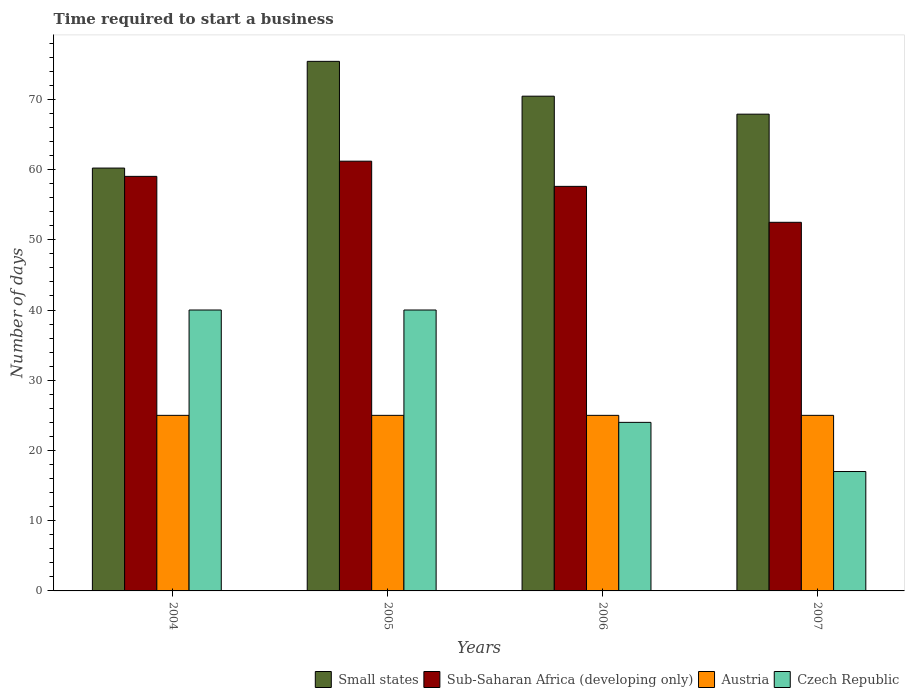How many different coloured bars are there?
Keep it short and to the point. 4. Are the number of bars on each tick of the X-axis equal?
Offer a terse response. Yes. In how many cases, is the number of bars for a given year not equal to the number of legend labels?
Your answer should be very brief. 0. What is the number of days required to start a business in Sub-Saharan Africa (developing only) in 2005?
Provide a succinct answer. 61.19. Across all years, what is the maximum number of days required to start a business in Austria?
Keep it short and to the point. 25. In which year was the number of days required to start a business in Small states maximum?
Your answer should be very brief. 2005. What is the total number of days required to start a business in Czech Republic in the graph?
Make the answer very short. 121. What is the difference between the number of days required to start a business in Small states in 2005 and that in 2006?
Provide a succinct answer. 4.96. What is the difference between the number of days required to start a business in Sub-Saharan Africa (developing only) in 2005 and the number of days required to start a business in Austria in 2004?
Provide a short and direct response. 36.19. What is the average number of days required to start a business in Small states per year?
Keep it short and to the point. 68.49. What is the ratio of the number of days required to start a business in Small states in 2006 to that in 2007?
Your answer should be compact. 1.04. What is the difference between the highest and the second highest number of days required to start a business in Austria?
Give a very brief answer. 0. What is the difference between the highest and the lowest number of days required to start a business in Sub-Saharan Africa (developing only)?
Offer a terse response. 8.7. Is it the case that in every year, the sum of the number of days required to start a business in Czech Republic and number of days required to start a business in Small states is greater than the sum of number of days required to start a business in Austria and number of days required to start a business in Sub-Saharan Africa (developing only)?
Provide a succinct answer. Yes. What does the 4th bar from the left in 2004 represents?
Give a very brief answer. Czech Republic. What does the 4th bar from the right in 2004 represents?
Keep it short and to the point. Small states. Is it the case that in every year, the sum of the number of days required to start a business in Sub-Saharan Africa (developing only) and number of days required to start a business in Czech Republic is greater than the number of days required to start a business in Small states?
Provide a short and direct response. Yes. Are all the bars in the graph horizontal?
Your answer should be compact. No. What is the difference between two consecutive major ticks on the Y-axis?
Provide a succinct answer. 10. Are the values on the major ticks of Y-axis written in scientific E-notation?
Make the answer very short. No. Where does the legend appear in the graph?
Give a very brief answer. Bottom right. How many legend labels are there?
Your answer should be very brief. 4. How are the legend labels stacked?
Your response must be concise. Horizontal. What is the title of the graph?
Offer a terse response. Time required to start a business. What is the label or title of the Y-axis?
Offer a very short reply. Number of days. What is the Number of days of Small states in 2004?
Ensure brevity in your answer.  60.21. What is the Number of days in Sub-Saharan Africa (developing only) in 2004?
Give a very brief answer. 59.03. What is the Number of days in Austria in 2004?
Give a very brief answer. 25. What is the Number of days in Small states in 2005?
Offer a terse response. 75.41. What is the Number of days of Sub-Saharan Africa (developing only) in 2005?
Offer a very short reply. 61.19. What is the Number of days in Czech Republic in 2005?
Your answer should be very brief. 40. What is the Number of days of Small states in 2006?
Ensure brevity in your answer.  70.45. What is the Number of days of Sub-Saharan Africa (developing only) in 2006?
Provide a succinct answer. 57.6. What is the Number of days in Austria in 2006?
Provide a short and direct response. 25. What is the Number of days in Czech Republic in 2006?
Your answer should be compact. 24. What is the Number of days of Small states in 2007?
Ensure brevity in your answer.  67.88. What is the Number of days of Sub-Saharan Africa (developing only) in 2007?
Your answer should be compact. 52.49. What is the Number of days in Czech Republic in 2007?
Offer a terse response. 17. Across all years, what is the maximum Number of days in Small states?
Your answer should be very brief. 75.41. Across all years, what is the maximum Number of days of Sub-Saharan Africa (developing only)?
Your answer should be very brief. 61.19. Across all years, what is the maximum Number of days in Austria?
Provide a short and direct response. 25. Across all years, what is the minimum Number of days of Small states?
Ensure brevity in your answer.  60.21. Across all years, what is the minimum Number of days in Sub-Saharan Africa (developing only)?
Make the answer very short. 52.49. Across all years, what is the minimum Number of days in Austria?
Your response must be concise. 25. What is the total Number of days of Small states in the graph?
Your response must be concise. 273.95. What is the total Number of days of Sub-Saharan Africa (developing only) in the graph?
Your response must be concise. 230.31. What is the total Number of days in Austria in the graph?
Offer a very short reply. 100. What is the total Number of days in Czech Republic in the graph?
Your response must be concise. 121. What is the difference between the Number of days of Small states in 2004 and that in 2005?
Offer a very short reply. -15.19. What is the difference between the Number of days in Sub-Saharan Africa (developing only) in 2004 and that in 2005?
Your answer should be compact. -2.16. What is the difference between the Number of days in Austria in 2004 and that in 2005?
Offer a very short reply. 0. What is the difference between the Number of days of Czech Republic in 2004 and that in 2005?
Your response must be concise. 0. What is the difference between the Number of days of Small states in 2004 and that in 2006?
Offer a terse response. -10.24. What is the difference between the Number of days of Sub-Saharan Africa (developing only) in 2004 and that in 2006?
Give a very brief answer. 1.42. What is the difference between the Number of days of Small states in 2004 and that in 2007?
Keep it short and to the point. -7.67. What is the difference between the Number of days of Sub-Saharan Africa (developing only) in 2004 and that in 2007?
Ensure brevity in your answer.  6.54. What is the difference between the Number of days of Austria in 2004 and that in 2007?
Your answer should be compact. 0. What is the difference between the Number of days of Small states in 2005 and that in 2006?
Your answer should be very brief. 4.96. What is the difference between the Number of days in Sub-Saharan Africa (developing only) in 2005 and that in 2006?
Keep it short and to the point. 3.59. What is the difference between the Number of days of Austria in 2005 and that in 2006?
Give a very brief answer. 0. What is the difference between the Number of days in Small states in 2005 and that in 2007?
Provide a succinct answer. 7.52. What is the difference between the Number of days of Sub-Saharan Africa (developing only) in 2005 and that in 2007?
Your answer should be compact. 8.7. What is the difference between the Number of days in Small states in 2006 and that in 2007?
Offer a terse response. 2.56. What is the difference between the Number of days in Sub-Saharan Africa (developing only) in 2006 and that in 2007?
Provide a short and direct response. 5.12. What is the difference between the Number of days of Austria in 2006 and that in 2007?
Ensure brevity in your answer.  0. What is the difference between the Number of days of Czech Republic in 2006 and that in 2007?
Keep it short and to the point. 7. What is the difference between the Number of days of Small states in 2004 and the Number of days of Sub-Saharan Africa (developing only) in 2005?
Keep it short and to the point. -0.98. What is the difference between the Number of days in Small states in 2004 and the Number of days in Austria in 2005?
Your answer should be very brief. 35.21. What is the difference between the Number of days of Small states in 2004 and the Number of days of Czech Republic in 2005?
Your answer should be compact. 20.21. What is the difference between the Number of days of Sub-Saharan Africa (developing only) in 2004 and the Number of days of Austria in 2005?
Your answer should be very brief. 34.03. What is the difference between the Number of days of Sub-Saharan Africa (developing only) in 2004 and the Number of days of Czech Republic in 2005?
Your response must be concise. 19.03. What is the difference between the Number of days in Small states in 2004 and the Number of days in Sub-Saharan Africa (developing only) in 2006?
Your response must be concise. 2.61. What is the difference between the Number of days in Small states in 2004 and the Number of days in Austria in 2006?
Make the answer very short. 35.21. What is the difference between the Number of days in Small states in 2004 and the Number of days in Czech Republic in 2006?
Make the answer very short. 36.21. What is the difference between the Number of days in Sub-Saharan Africa (developing only) in 2004 and the Number of days in Austria in 2006?
Keep it short and to the point. 34.03. What is the difference between the Number of days of Sub-Saharan Africa (developing only) in 2004 and the Number of days of Czech Republic in 2006?
Your response must be concise. 35.03. What is the difference between the Number of days in Small states in 2004 and the Number of days in Sub-Saharan Africa (developing only) in 2007?
Provide a short and direct response. 7.72. What is the difference between the Number of days of Small states in 2004 and the Number of days of Austria in 2007?
Offer a terse response. 35.21. What is the difference between the Number of days of Small states in 2004 and the Number of days of Czech Republic in 2007?
Your answer should be very brief. 43.21. What is the difference between the Number of days in Sub-Saharan Africa (developing only) in 2004 and the Number of days in Austria in 2007?
Provide a succinct answer. 34.03. What is the difference between the Number of days of Sub-Saharan Africa (developing only) in 2004 and the Number of days of Czech Republic in 2007?
Provide a short and direct response. 42.03. What is the difference between the Number of days of Small states in 2005 and the Number of days of Sub-Saharan Africa (developing only) in 2006?
Give a very brief answer. 17.8. What is the difference between the Number of days in Small states in 2005 and the Number of days in Austria in 2006?
Your answer should be compact. 50.41. What is the difference between the Number of days of Small states in 2005 and the Number of days of Czech Republic in 2006?
Make the answer very short. 51.41. What is the difference between the Number of days in Sub-Saharan Africa (developing only) in 2005 and the Number of days in Austria in 2006?
Your answer should be compact. 36.19. What is the difference between the Number of days in Sub-Saharan Africa (developing only) in 2005 and the Number of days in Czech Republic in 2006?
Provide a succinct answer. 37.19. What is the difference between the Number of days in Austria in 2005 and the Number of days in Czech Republic in 2006?
Your response must be concise. 1. What is the difference between the Number of days in Small states in 2005 and the Number of days in Sub-Saharan Africa (developing only) in 2007?
Ensure brevity in your answer.  22.92. What is the difference between the Number of days of Small states in 2005 and the Number of days of Austria in 2007?
Your answer should be very brief. 50.41. What is the difference between the Number of days of Small states in 2005 and the Number of days of Czech Republic in 2007?
Your answer should be compact. 58.41. What is the difference between the Number of days of Sub-Saharan Africa (developing only) in 2005 and the Number of days of Austria in 2007?
Offer a terse response. 36.19. What is the difference between the Number of days of Sub-Saharan Africa (developing only) in 2005 and the Number of days of Czech Republic in 2007?
Your answer should be very brief. 44.19. What is the difference between the Number of days in Small states in 2006 and the Number of days in Sub-Saharan Africa (developing only) in 2007?
Your answer should be compact. 17.96. What is the difference between the Number of days in Small states in 2006 and the Number of days in Austria in 2007?
Ensure brevity in your answer.  45.45. What is the difference between the Number of days in Small states in 2006 and the Number of days in Czech Republic in 2007?
Offer a very short reply. 53.45. What is the difference between the Number of days in Sub-Saharan Africa (developing only) in 2006 and the Number of days in Austria in 2007?
Offer a terse response. 32.6. What is the difference between the Number of days in Sub-Saharan Africa (developing only) in 2006 and the Number of days in Czech Republic in 2007?
Keep it short and to the point. 40.6. What is the average Number of days in Small states per year?
Offer a terse response. 68.49. What is the average Number of days of Sub-Saharan Africa (developing only) per year?
Make the answer very short. 57.58. What is the average Number of days in Austria per year?
Provide a succinct answer. 25. What is the average Number of days in Czech Republic per year?
Your answer should be very brief. 30.25. In the year 2004, what is the difference between the Number of days in Small states and Number of days in Sub-Saharan Africa (developing only)?
Give a very brief answer. 1.18. In the year 2004, what is the difference between the Number of days in Small states and Number of days in Austria?
Offer a terse response. 35.21. In the year 2004, what is the difference between the Number of days in Small states and Number of days in Czech Republic?
Offer a terse response. 20.21. In the year 2004, what is the difference between the Number of days of Sub-Saharan Africa (developing only) and Number of days of Austria?
Your response must be concise. 34.03. In the year 2004, what is the difference between the Number of days in Sub-Saharan Africa (developing only) and Number of days in Czech Republic?
Your answer should be very brief. 19.03. In the year 2005, what is the difference between the Number of days in Small states and Number of days in Sub-Saharan Africa (developing only)?
Offer a very short reply. 14.21. In the year 2005, what is the difference between the Number of days in Small states and Number of days in Austria?
Offer a very short reply. 50.41. In the year 2005, what is the difference between the Number of days in Small states and Number of days in Czech Republic?
Make the answer very short. 35.41. In the year 2005, what is the difference between the Number of days of Sub-Saharan Africa (developing only) and Number of days of Austria?
Your answer should be compact. 36.19. In the year 2005, what is the difference between the Number of days in Sub-Saharan Africa (developing only) and Number of days in Czech Republic?
Offer a very short reply. 21.19. In the year 2006, what is the difference between the Number of days of Small states and Number of days of Sub-Saharan Africa (developing only)?
Your answer should be very brief. 12.84. In the year 2006, what is the difference between the Number of days in Small states and Number of days in Austria?
Make the answer very short. 45.45. In the year 2006, what is the difference between the Number of days in Small states and Number of days in Czech Republic?
Make the answer very short. 46.45. In the year 2006, what is the difference between the Number of days of Sub-Saharan Africa (developing only) and Number of days of Austria?
Keep it short and to the point. 32.6. In the year 2006, what is the difference between the Number of days of Sub-Saharan Africa (developing only) and Number of days of Czech Republic?
Offer a terse response. 33.6. In the year 2006, what is the difference between the Number of days of Austria and Number of days of Czech Republic?
Offer a very short reply. 1. In the year 2007, what is the difference between the Number of days in Small states and Number of days in Sub-Saharan Africa (developing only)?
Keep it short and to the point. 15.4. In the year 2007, what is the difference between the Number of days of Small states and Number of days of Austria?
Your response must be concise. 42.88. In the year 2007, what is the difference between the Number of days of Small states and Number of days of Czech Republic?
Your answer should be compact. 50.88. In the year 2007, what is the difference between the Number of days in Sub-Saharan Africa (developing only) and Number of days in Austria?
Your answer should be compact. 27.49. In the year 2007, what is the difference between the Number of days in Sub-Saharan Africa (developing only) and Number of days in Czech Republic?
Make the answer very short. 35.49. In the year 2007, what is the difference between the Number of days of Austria and Number of days of Czech Republic?
Provide a short and direct response. 8. What is the ratio of the Number of days in Small states in 2004 to that in 2005?
Offer a terse response. 0.8. What is the ratio of the Number of days in Sub-Saharan Africa (developing only) in 2004 to that in 2005?
Ensure brevity in your answer.  0.96. What is the ratio of the Number of days of Austria in 2004 to that in 2005?
Provide a succinct answer. 1. What is the ratio of the Number of days in Czech Republic in 2004 to that in 2005?
Provide a short and direct response. 1. What is the ratio of the Number of days of Small states in 2004 to that in 2006?
Offer a terse response. 0.85. What is the ratio of the Number of days in Sub-Saharan Africa (developing only) in 2004 to that in 2006?
Provide a succinct answer. 1.02. What is the ratio of the Number of days of Austria in 2004 to that in 2006?
Provide a succinct answer. 1. What is the ratio of the Number of days in Small states in 2004 to that in 2007?
Your answer should be very brief. 0.89. What is the ratio of the Number of days of Sub-Saharan Africa (developing only) in 2004 to that in 2007?
Your response must be concise. 1.12. What is the ratio of the Number of days of Czech Republic in 2004 to that in 2007?
Your response must be concise. 2.35. What is the ratio of the Number of days of Small states in 2005 to that in 2006?
Your answer should be compact. 1.07. What is the ratio of the Number of days of Sub-Saharan Africa (developing only) in 2005 to that in 2006?
Your answer should be compact. 1.06. What is the ratio of the Number of days in Small states in 2005 to that in 2007?
Offer a very short reply. 1.11. What is the ratio of the Number of days in Sub-Saharan Africa (developing only) in 2005 to that in 2007?
Make the answer very short. 1.17. What is the ratio of the Number of days of Czech Republic in 2005 to that in 2007?
Your answer should be compact. 2.35. What is the ratio of the Number of days in Small states in 2006 to that in 2007?
Your answer should be compact. 1.04. What is the ratio of the Number of days of Sub-Saharan Africa (developing only) in 2006 to that in 2007?
Offer a very short reply. 1.1. What is the ratio of the Number of days in Czech Republic in 2006 to that in 2007?
Give a very brief answer. 1.41. What is the difference between the highest and the second highest Number of days in Small states?
Ensure brevity in your answer.  4.96. What is the difference between the highest and the second highest Number of days of Sub-Saharan Africa (developing only)?
Your answer should be very brief. 2.16. What is the difference between the highest and the second highest Number of days of Austria?
Make the answer very short. 0. What is the difference between the highest and the lowest Number of days in Small states?
Your answer should be very brief. 15.19. What is the difference between the highest and the lowest Number of days of Sub-Saharan Africa (developing only)?
Your response must be concise. 8.7. What is the difference between the highest and the lowest Number of days in Austria?
Your answer should be very brief. 0. What is the difference between the highest and the lowest Number of days in Czech Republic?
Your answer should be very brief. 23. 